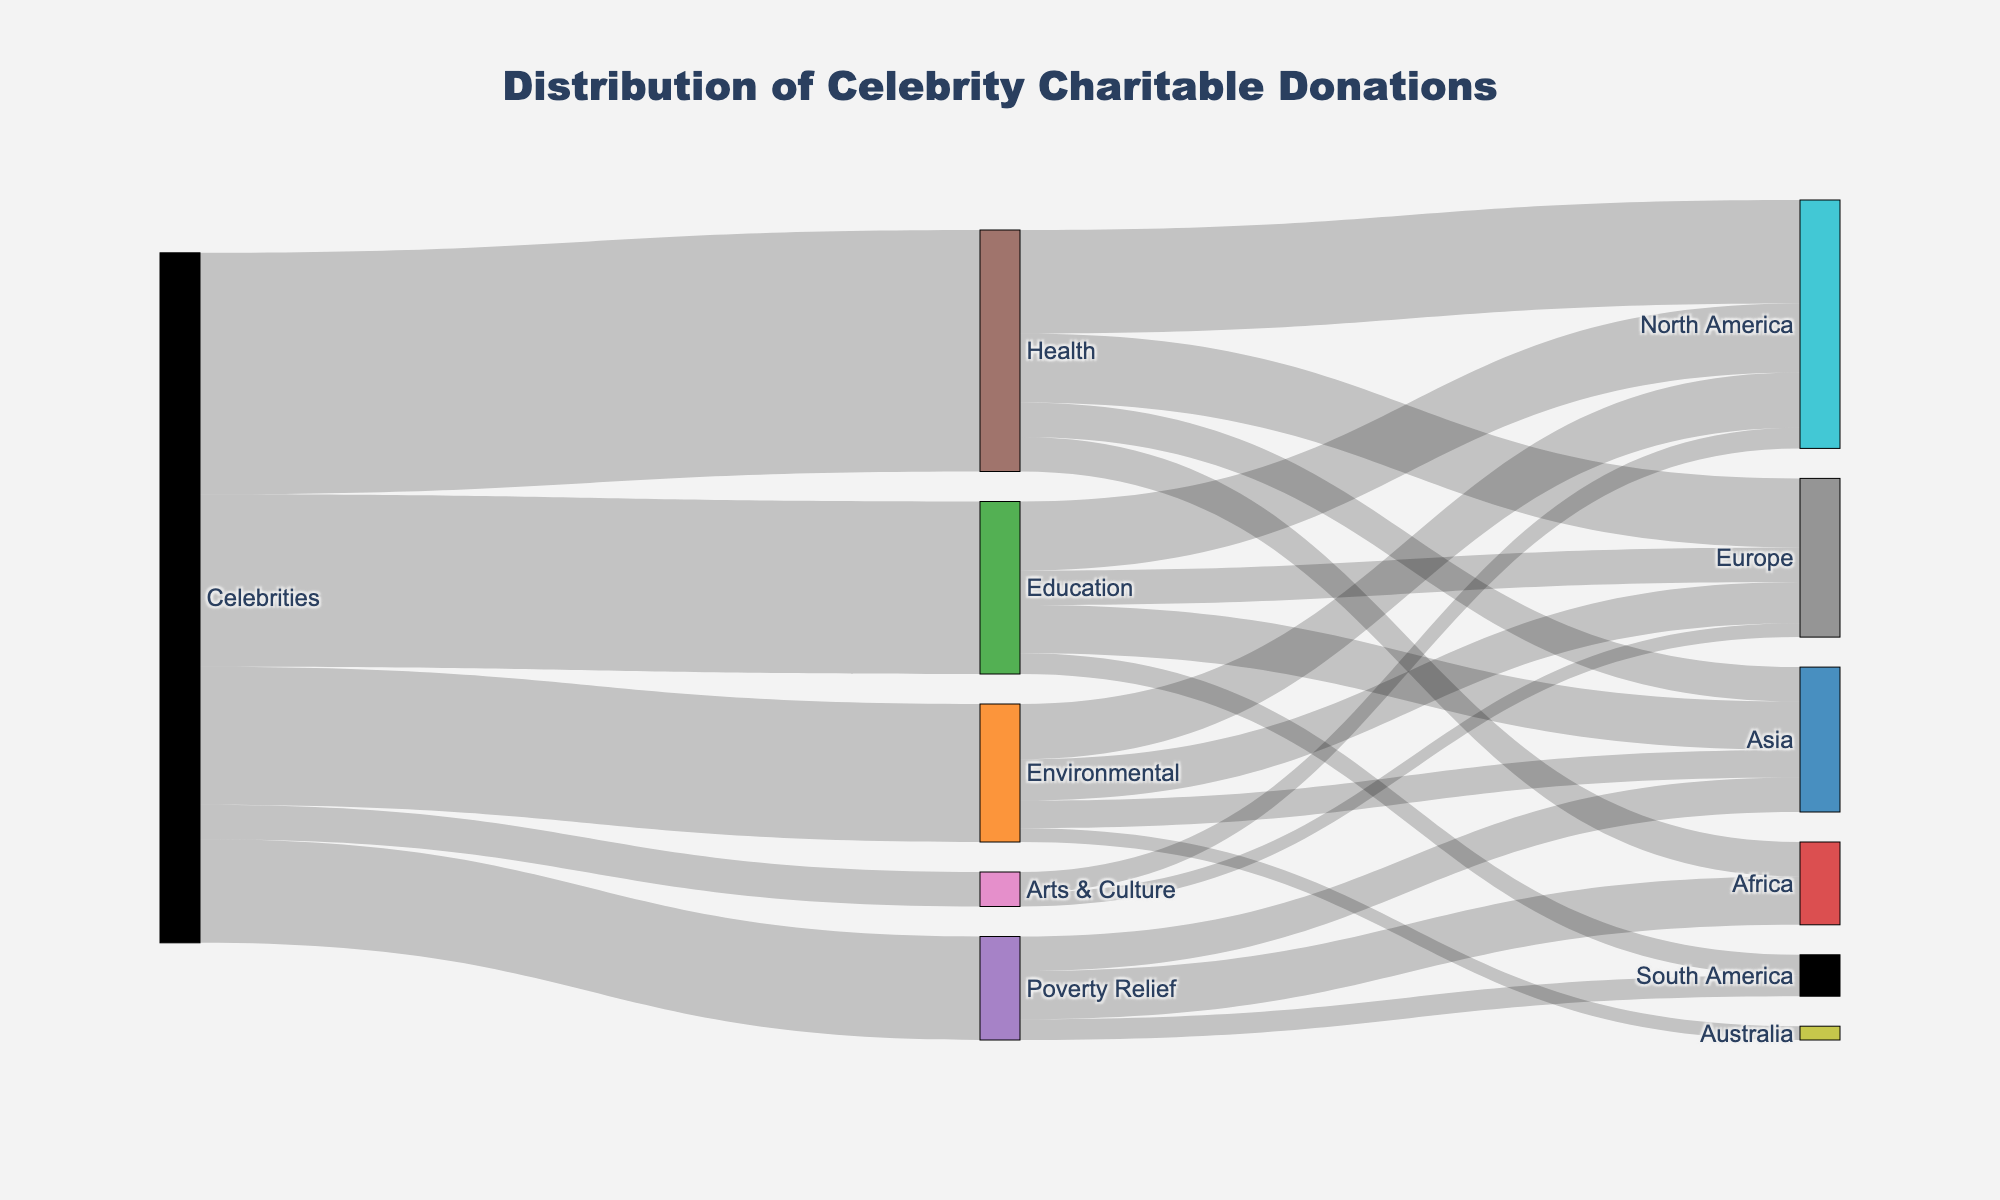What is the total number of celebrity donations directed towards Health causes? We need to find the branch labeled 'Health' that extends from 'Celebrities'. The value indicated is 35.
Answer: 35 Which geographical region receives the highest donation for Health? The branches coming from 'Health' indicate donations to various regions. Among North America (15), Europe (10), Asia (5), and Africa (5), North America has the highest value.
Answer: North America How does the donation amount for Education in Asia compare to that in Europe? Trace the branches from 'Education' to their respective regions; Asia receives 7 and Europe receives 5. Comparing these values, Asia receives more than Europe.
Answer: Asia > Europe If you sum up donations targeted at Poverty Relief across different regions, what do you get? The values for Poverty Relief donations are Africa (7), Asia (5), and South America (3). Adding these up: 7 + 5 + 3 = 15.
Answer: 15 Which cause receives the least amount of donations from celebrities? Review the main branches extending from 'Celebrities' to identify the smallest value. Arts & Culture has the smallest value at 5.
Answer: Arts & Culture What percentage of celebrity donations goes to Environmental causes? The total donations sum to 35 + 25 + 20 + 15 + 5 = 100. The donation for Environmental causes is 20. To find the percentage: (20/100) * 100% = 20%.
Answer: 20% Can you find the geographical region that receives donations under more than one cause and list the causes? North America receives donations from Health (15), Education (10), Environmental (8), and Arts & Culture (3). Therefore, it receives donations from multiple causes.
Answer: Health, Education, Environmental, Arts & Culture What is the combined value of donations to all regions under Education? Add together the donations under Education for different regions: North America (10), Europe (5), Asia (7), and South America (3). The total is 10 + 5 + 7 + 3 = 25.
Answer: 25 Which cause has the most diverse geographical distribution in terms of receiving donations? Compare the number of distinct regions for each cause. Health (4), Education (4), Environmental (4), Poverty Relief (3), and Arts & Culture (2). Health, Education, and Environmental all tie for the highest diversity.
Answer: Health, Education, Environmental How much more do celebrities donate to Health compared to Arts & Culture? Subtract the donation to Arts & Culture (5) from the donation to Health (35). The difference is 35 - 5 = 30.
Answer: 30 